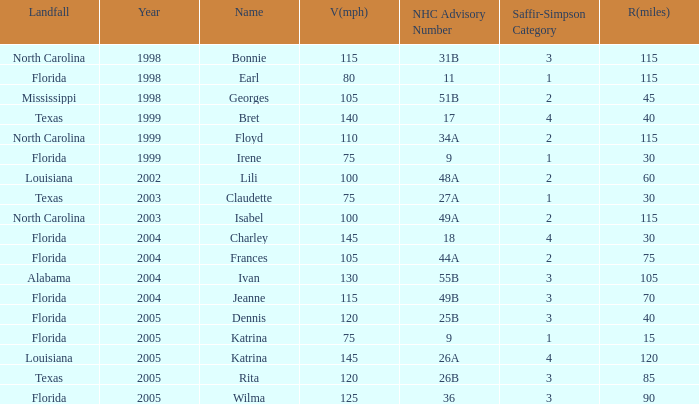Which landfall was in category 1 for Saffir-Simpson in 1999? Florida. 